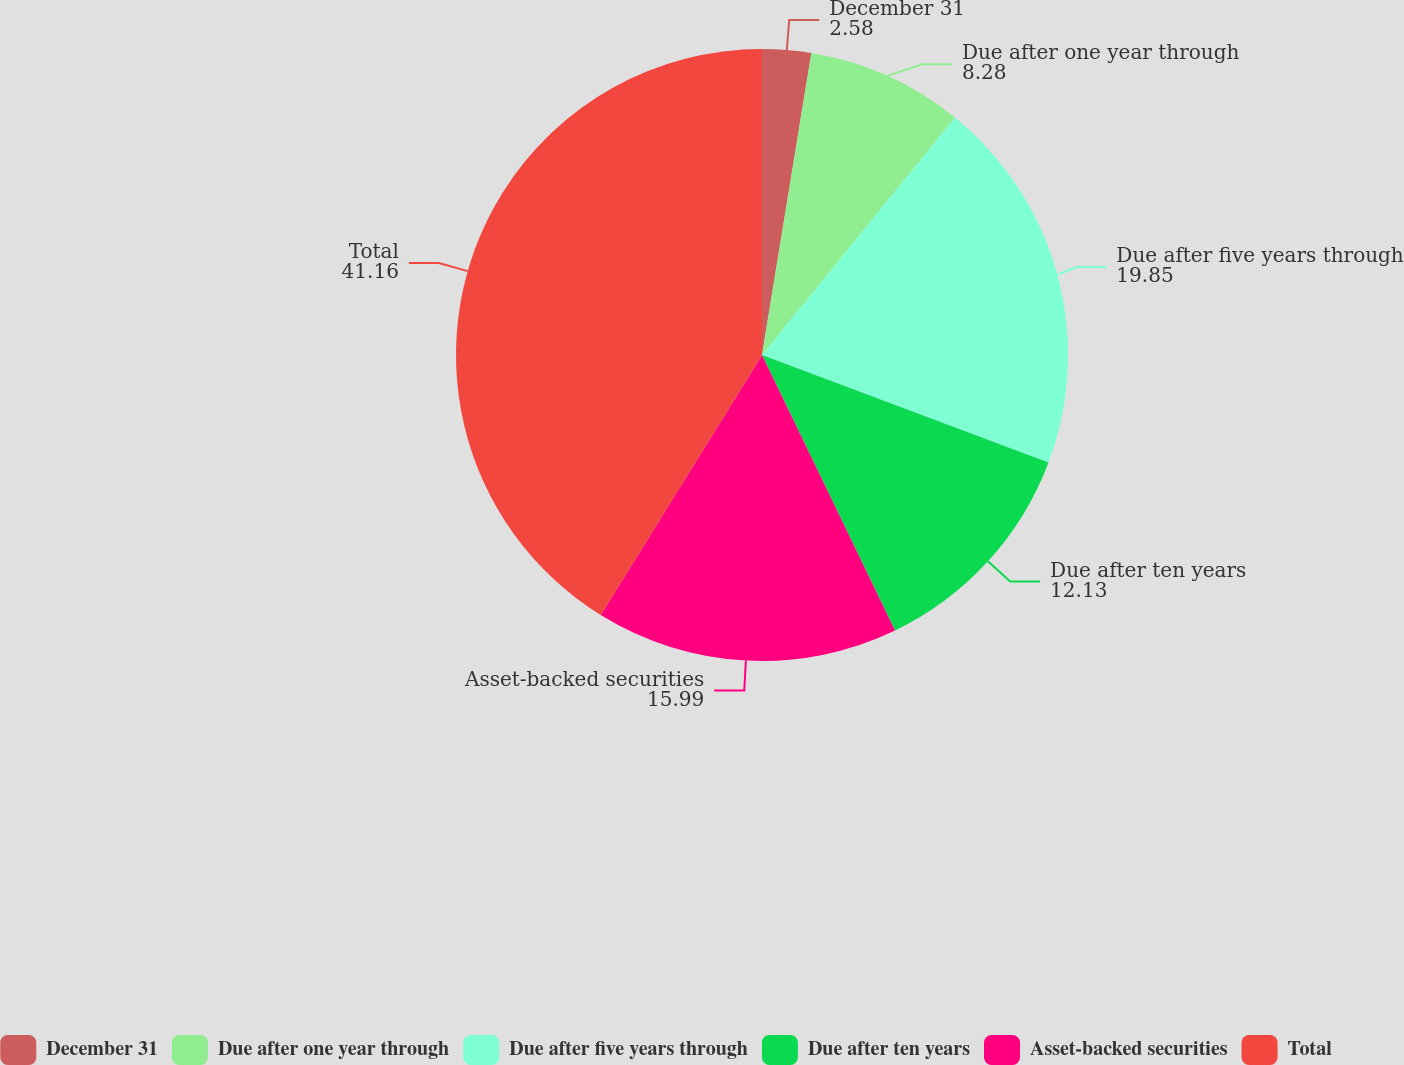<chart> <loc_0><loc_0><loc_500><loc_500><pie_chart><fcel>December 31<fcel>Due after one year through<fcel>Due after five years through<fcel>Due after ten years<fcel>Asset-backed securities<fcel>Total<nl><fcel>2.58%<fcel>8.28%<fcel>19.85%<fcel>12.13%<fcel>15.99%<fcel>41.16%<nl></chart> 